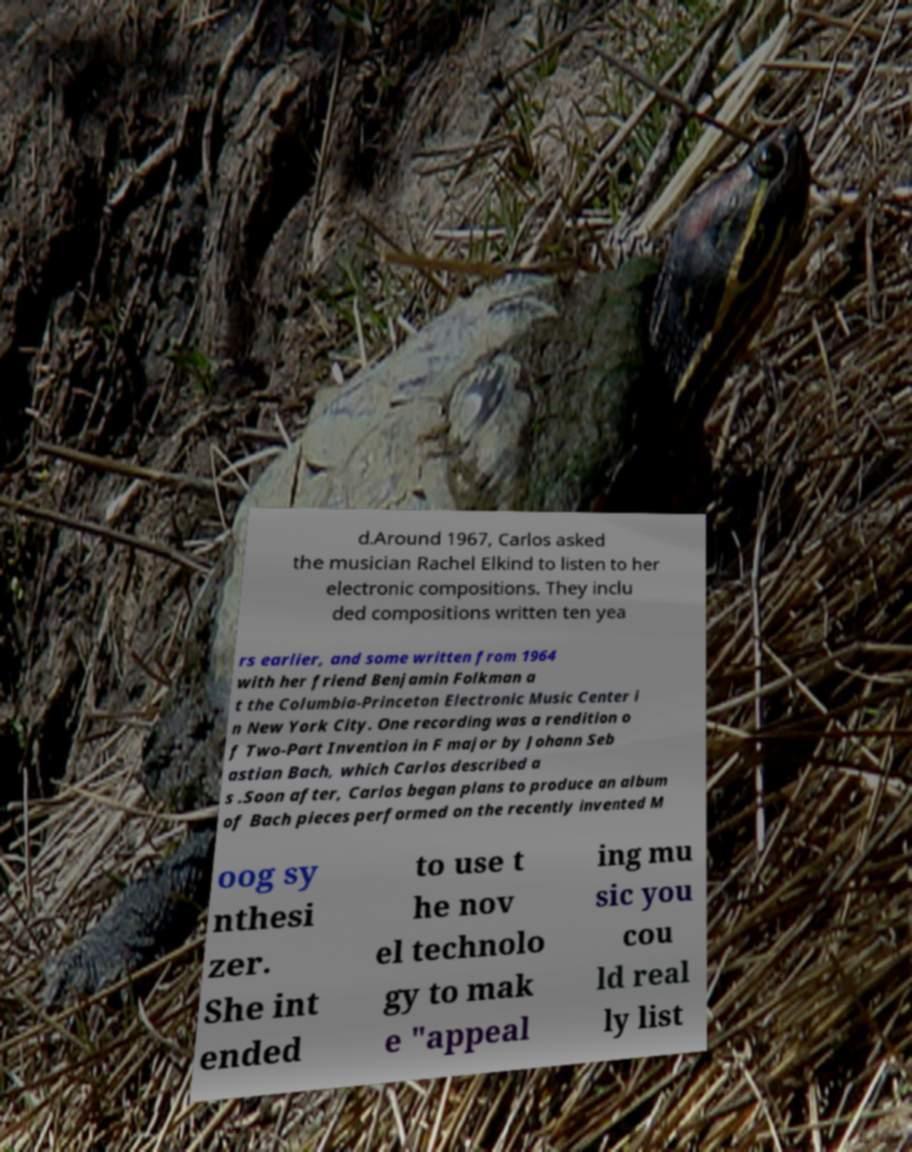Please identify and transcribe the text found in this image. d.Around 1967, Carlos asked the musician Rachel Elkind to listen to her electronic compositions. They inclu ded compositions written ten yea rs earlier, and some written from 1964 with her friend Benjamin Folkman a t the Columbia-Princeton Electronic Music Center i n New York City. One recording was a rendition o f Two-Part Invention in F major by Johann Seb astian Bach, which Carlos described a s .Soon after, Carlos began plans to produce an album of Bach pieces performed on the recently invented M oog sy nthesi zer. She int ended to use t he nov el technolo gy to mak e "appeal ing mu sic you cou ld real ly list 